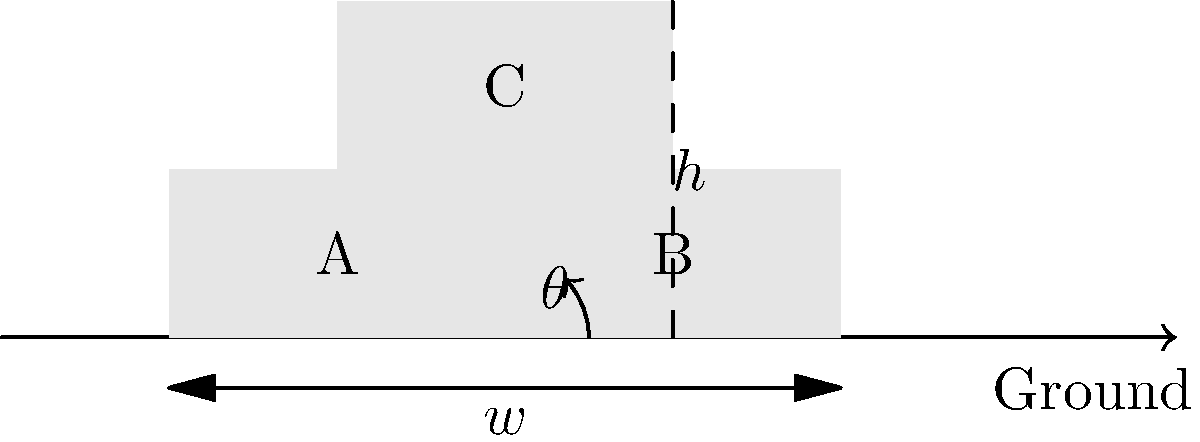A shipping company wants to optimize its container stacking process. They stack two containers (A and B) side by side on the ground, each with a width of $w$ meters. A third container (C) is placed on top at an angle $\theta$ to maximize stability and space utilization. If the height of the stack is $h$ meters, express $h$ in terms of $w$ and $\theta$. Then, find the optimal angle $\theta$ that maximizes the height $h$. Let's approach this step-by-step:

1) First, we need to express $h$ in terms of $w$ and $\theta$:
   
   The width of the base (containers A and B) is $2w$.
   The top container (C) forms a right triangle with the base.
   
   Using trigonometry, we can say:
   
   $$\tan \theta = \frac{h}{w}$$

   Rearranging this, we get:
   
   $$h = w \tan \theta$$

2) Now, to find the optimal angle that maximizes height, we need to consider the constraint:
   
   The length of container C must equal the width of the base ($2w$).
   
   Using the Pythagorean theorem:
   
   $$w^2 + h^2 = (2w)^2$$

3) Substituting our expression for $h$:

   $$w^2 + (w \tan \theta)^2 = 4w^2$$

4) Simplifying:

   $$1 + \tan^2 \theta = 4$$
   $$\tan^2 \theta = 3$$
   $$\tan \theta = \sqrt{3}$$

5) To find $\theta$, we take the inverse tangent:

   $$\theta = \arctan(\sqrt{3}) \approx 60°$$

6) We can verify that this indeed maximizes $h$ by taking the derivative of $h$ with respect to $\theta$ and setting it to zero, but that's beyond the scope of this problem.

Therefore, the optimal angle for stacking is approximately 60°, which corresponds to an equilateral triangle configuration.
Answer: $h = w \tan \theta$; Optimal $\theta \approx 60°$ 